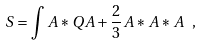Convert formula to latex. <formula><loc_0><loc_0><loc_500><loc_500>S = \int A * Q A + { \frac { 2 } { 3 } } A * A * A \ ,</formula> 